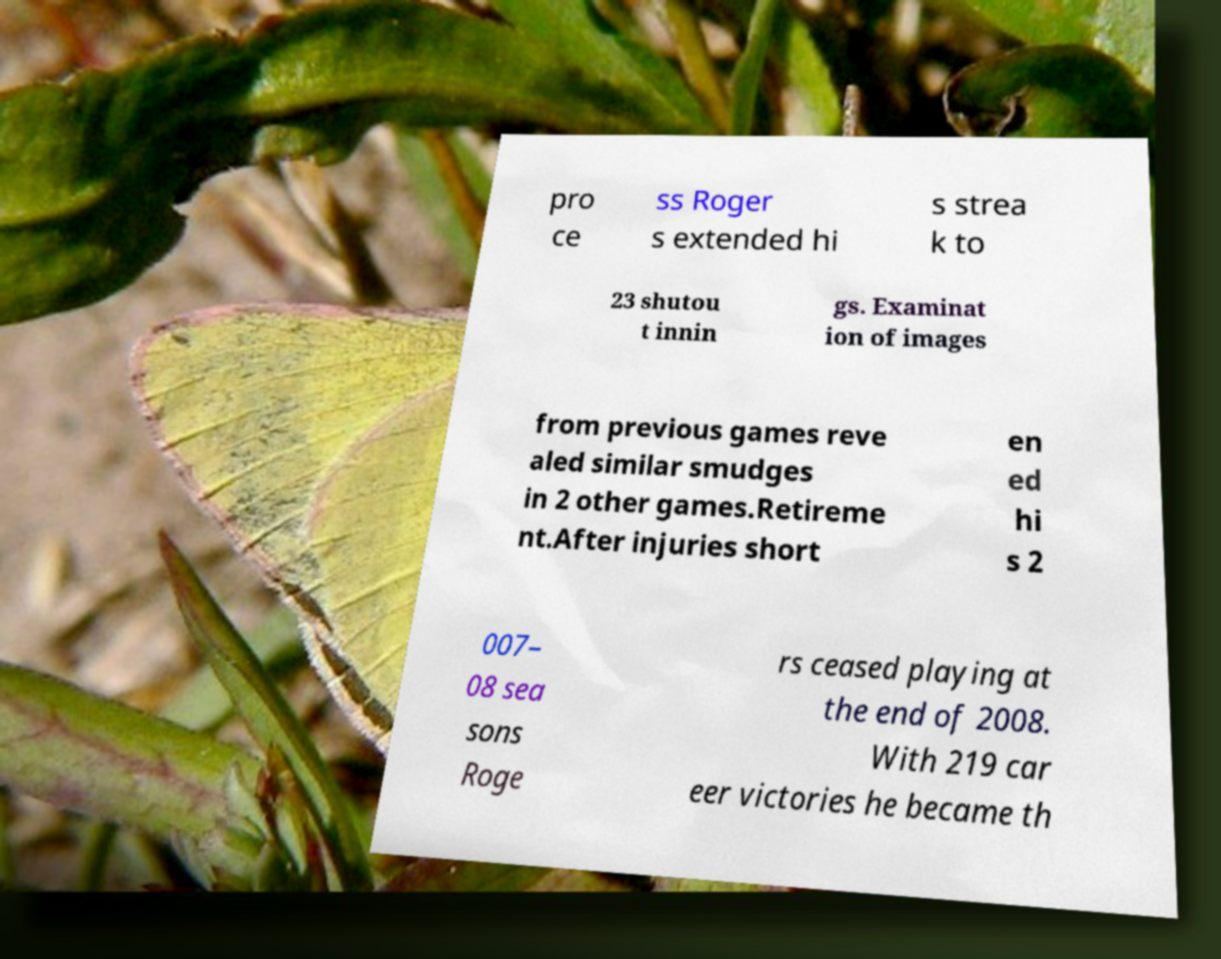There's text embedded in this image that I need extracted. Can you transcribe it verbatim? pro ce ss Roger s extended hi s strea k to 23 shutou t innin gs. Examinat ion of images from previous games reve aled similar smudges in 2 other games.Retireme nt.After injuries short en ed hi s 2 007– 08 sea sons Roge rs ceased playing at the end of 2008. With 219 car eer victories he became th 